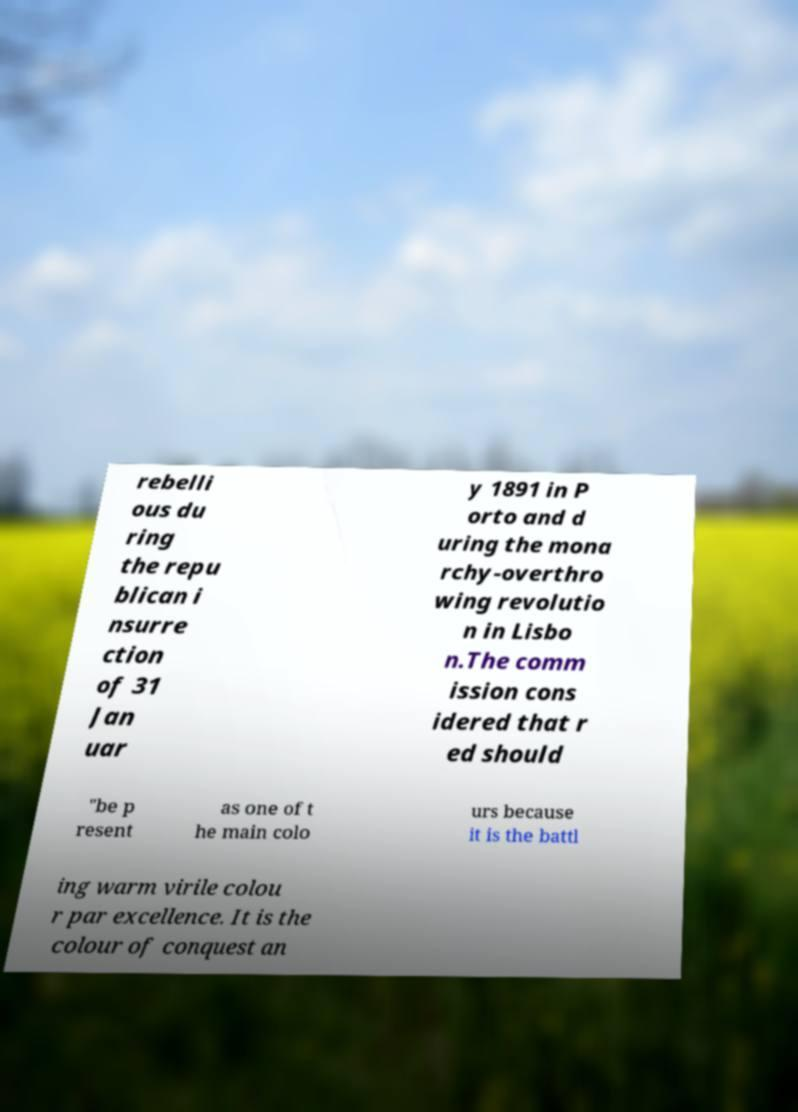There's text embedded in this image that I need extracted. Can you transcribe it verbatim? rebelli ous du ring the repu blican i nsurre ction of 31 Jan uar y 1891 in P orto and d uring the mona rchy-overthro wing revolutio n in Lisbo n.The comm ission cons idered that r ed should "be p resent as one of t he main colo urs because it is the battl ing warm virile colou r par excellence. It is the colour of conquest an 